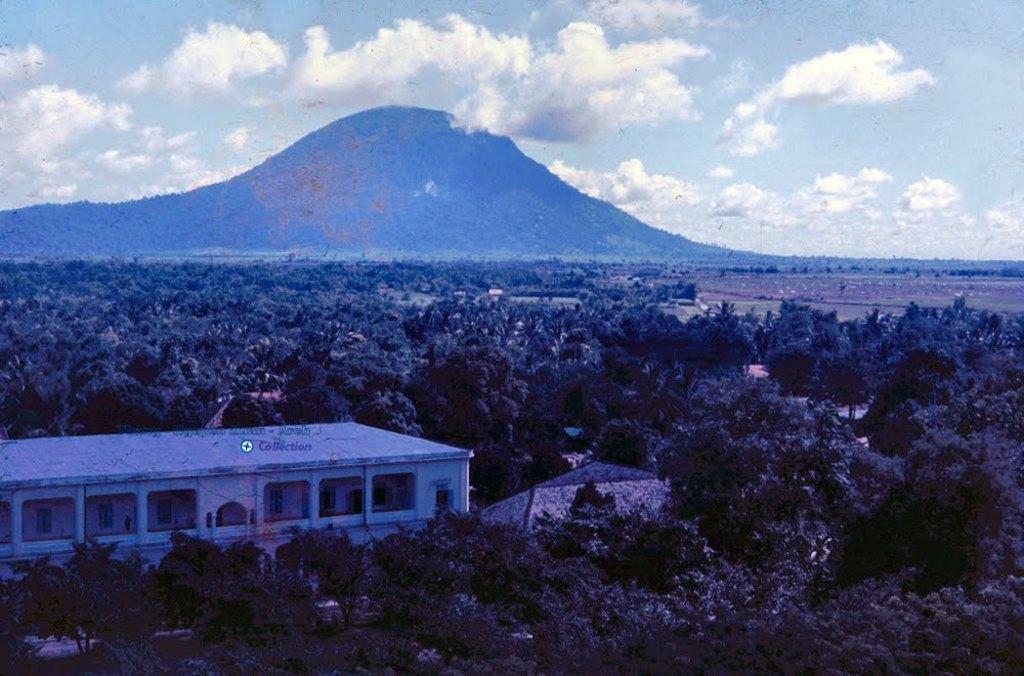How would you summarize this image in a sentence or two? In this image I can see number of trees and few buildings. In the background I can see the ground, a mountain and the sky. 